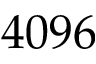<formula> <loc_0><loc_0><loc_500><loc_500>4 0 9 6</formula> 